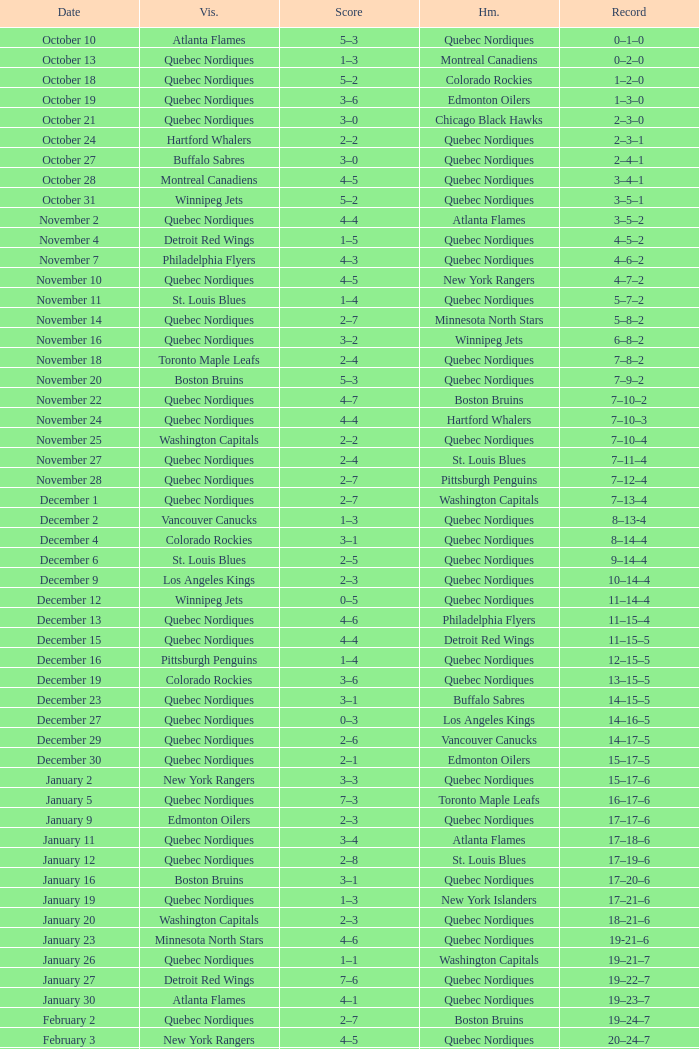Which Home has a Record of 11–14–4? Quebec Nordiques. 